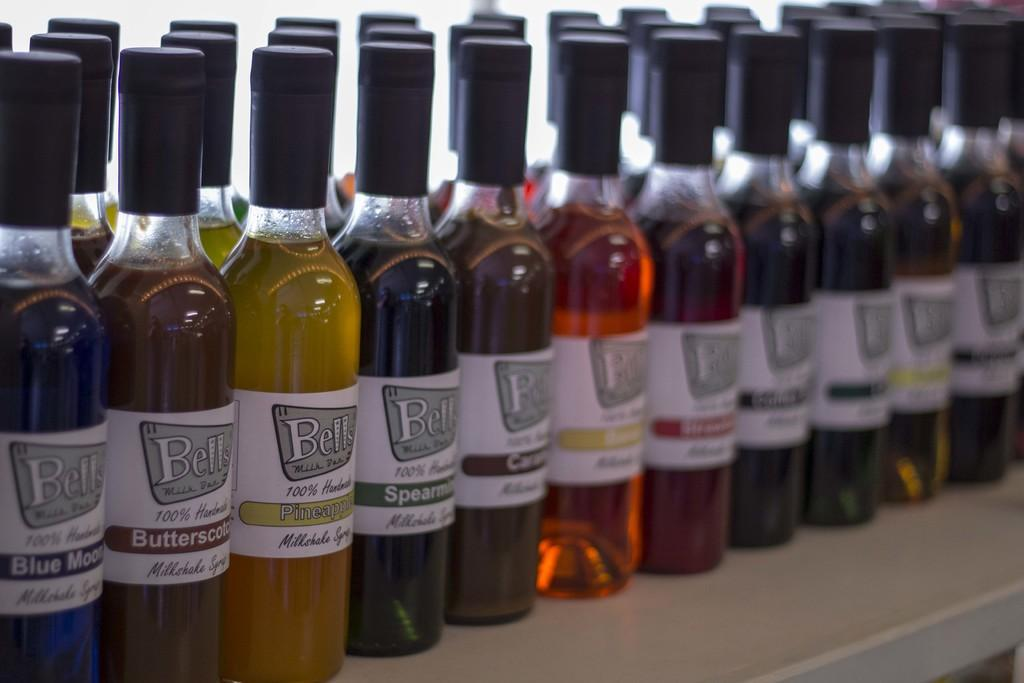What objects are present in the image? There are bottles in the image. What is inside the bottles? The bottles contain colorful liquid. Where are the bottles located? The bottles are on a table. What type of pin can be seen holding the bottles together in the image? There is no pin present in the image, and the bottles are not held together. 